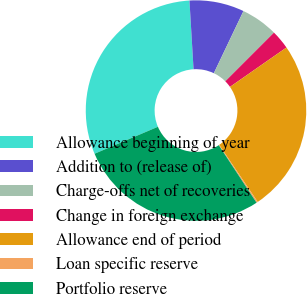Convert chart to OTSL. <chart><loc_0><loc_0><loc_500><loc_500><pie_chart><fcel>Allowance beginning of year<fcel>Addition to (release of)<fcel>Charge-offs net of recoveries<fcel>Change in foreign exchange<fcel>Allowance end of period<fcel>Loan specific reserve<fcel>Portfolio reserve<nl><fcel>30.46%<fcel>8.03%<fcel>5.42%<fcel>2.81%<fcel>25.24%<fcel>0.2%<fcel>27.85%<nl></chart> 